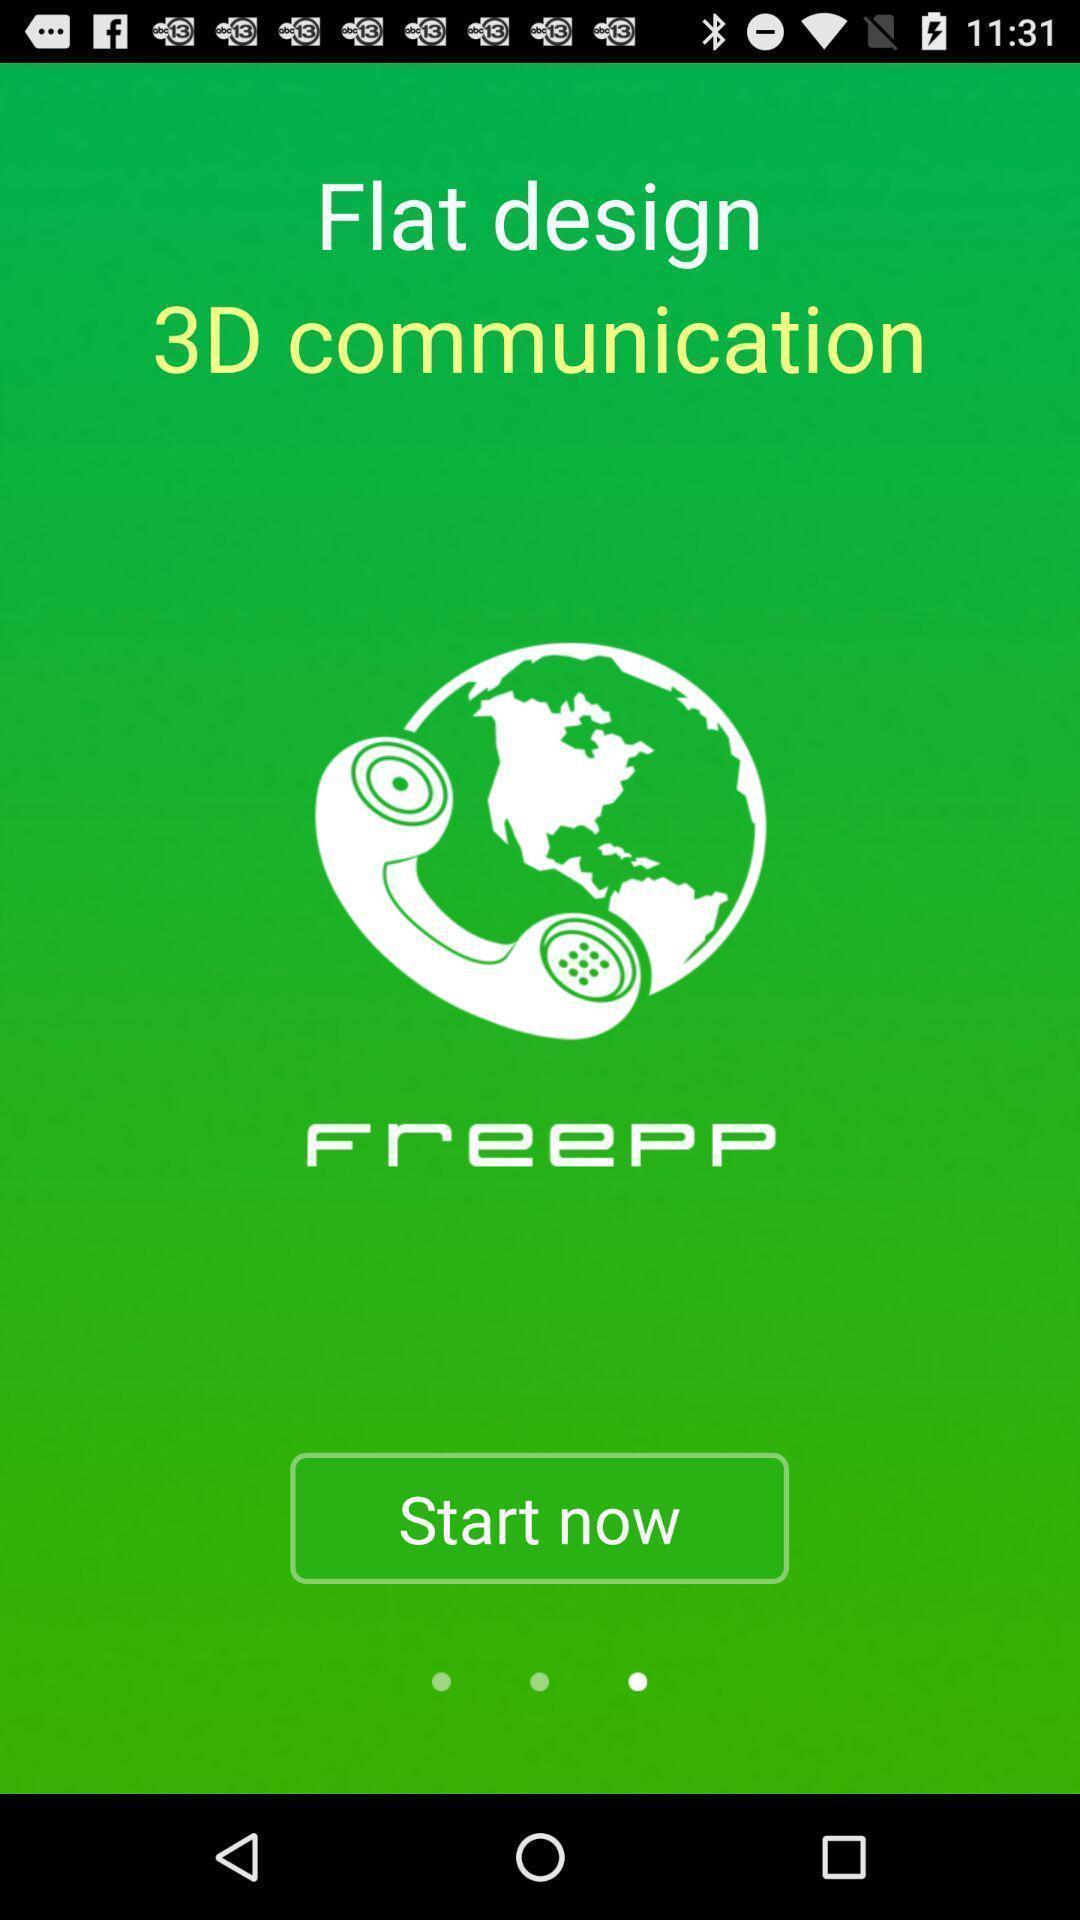Summarize the main components in this picture. Welcome page of social app. 